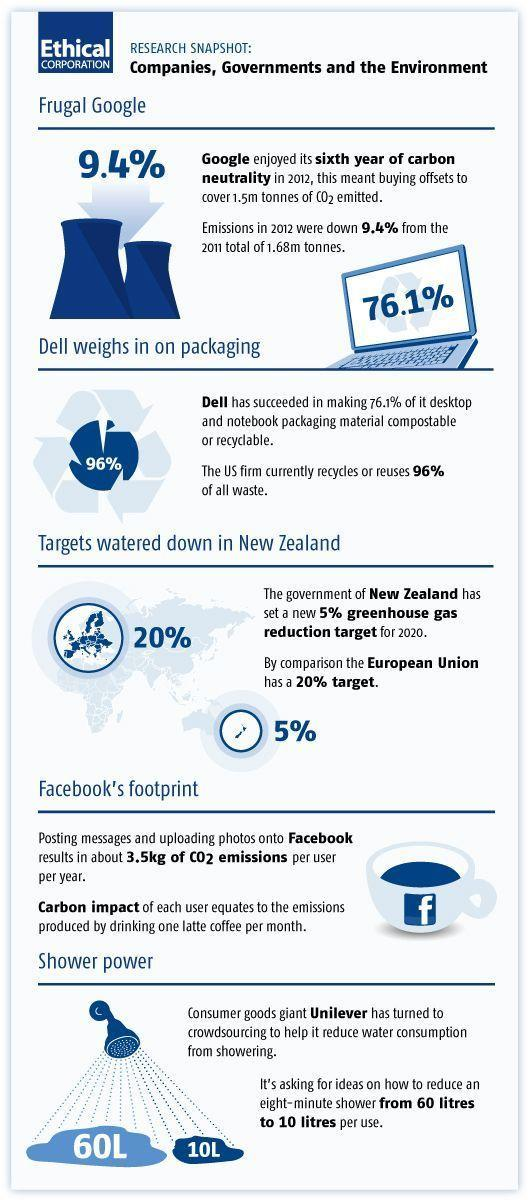What is total percentage of carbon emissions that NZ and EU hope to achieve for 2020?
Answer the question with a short phrase. 25% What is the water consumption target that Unilever is aiming to achieve, 60L, 10L, or 3.5L? 10L 